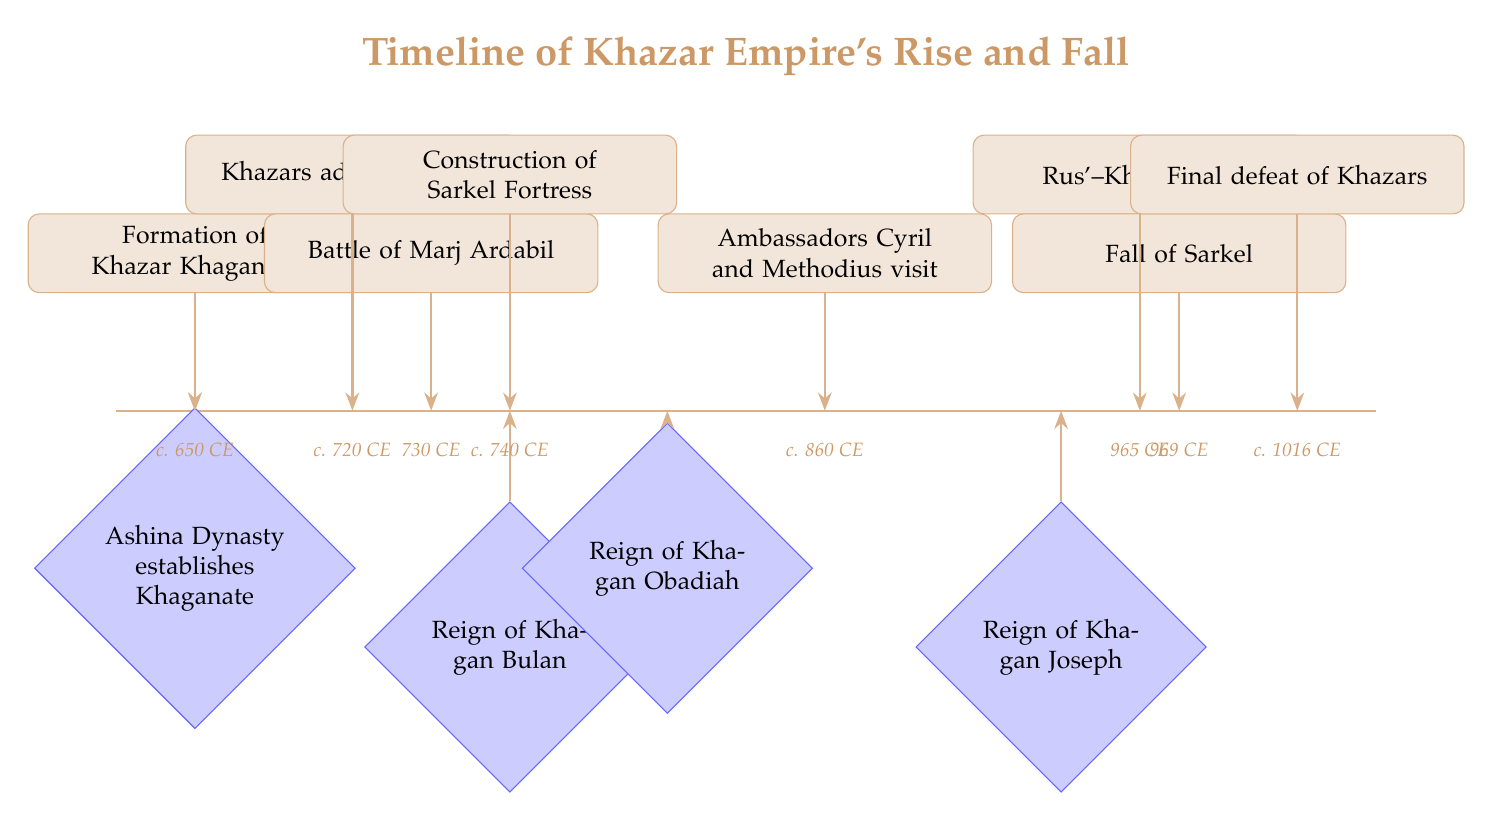What year did the formation of the Khazar Khaganate occur? The diagram shows that the formation of the Khazar Khaganate is marked at approximately 650 CE. This can be located at the leftmost event on the timeline.
Answer: 650 CE Which dynasty established the Khaganate? The diagram identifies the Ashina Dynasty as the dynasty that established the Khaganate. This information is found in the dynastic changes section at the bottom of the timeline.
Answer: Ashina Dynasty What major event took place around 740 CE? According to the timeline, the major event that occurred around 740 CE is the "Construction of Sarkel Fortress," which is represented at the specified point on the timeline.
Answer: Construction of Sarkel Fortress What event is linked with Khagan Joseph's reign? The event 'Rus'–Khazar War' is directly linked to the reign of Khagan Joseph since it occurs before his reign and is positioned higher on the timeline, indicating a chronological order of events.
Answer: Rus'–Khazar War How many dynastic changes are represented in the timeline? The timeline contains four distinct dynastic changes, as indicated by the four diamond shapes representing different dynasties along the bottom of the diagram.
Answer: 4 What approximate year is associated with the fall of Sarkel? The diagram marks the fall of Sarkel at approximately 969 CE, as indicated in the timeline near the corresponding event's label.
Answer: 969 CE Which event occurred immediately after the Khazars adopted Judaism? The event that occurs immediately after "Khazars adopt Judaism" is the "Battle of Marj Ardabil," shown as the next event on the timeline.
Answer: Battle of Marj Ardabil What is the final event listed on the timeline? The final event listed on the timeline is the "Final defeat of Khazars," which is shown towards the right end of the timeline, indicating the end of the Khazar Empire.
Answer: Final defeat of Khazars Which Khagan reigned after Bulan? The Khagan who reigned after Bulan is Khagan Obadiah, positioned in the sequence of dynastic changes below the timeline, indicating the order of rulers.
Answer: Khagan Obadiah 